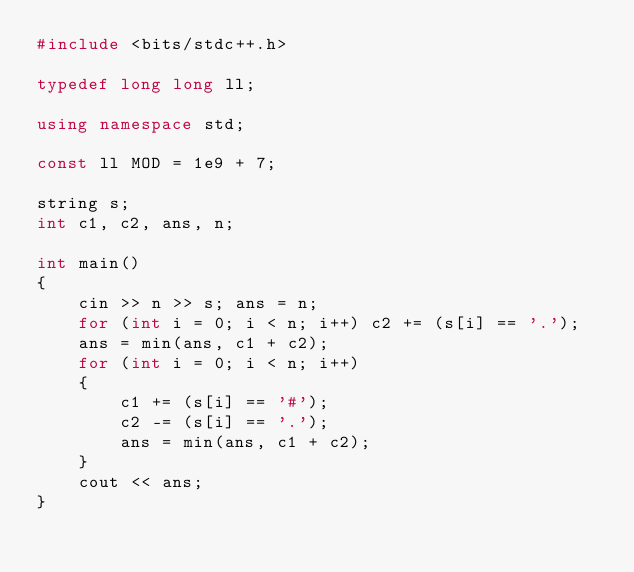Convert code to text. <code><loc_0><loc_0><loc_500><loc_500><_C++_>#include <bits/stdc++.h>

typedef long long ll;

using namespace std;

const ll MOD = 1e9 + 7;

string s;
int c1, c2, ans, n;

int main()
{
    cin >> n >> s; ans = n;
    for (int i = 0; i < n; i++) c2 += (s[i] == '.');
    ans = min(ans, c1 + c2);
    for (int i = 0; i < n; i++)
    {
        c1 += (s[i] == '#');
        c2 -= (s[i] == '.');
        ans = min(ans, c1 + c2);
    }
    cout << ans;
}
</code> 